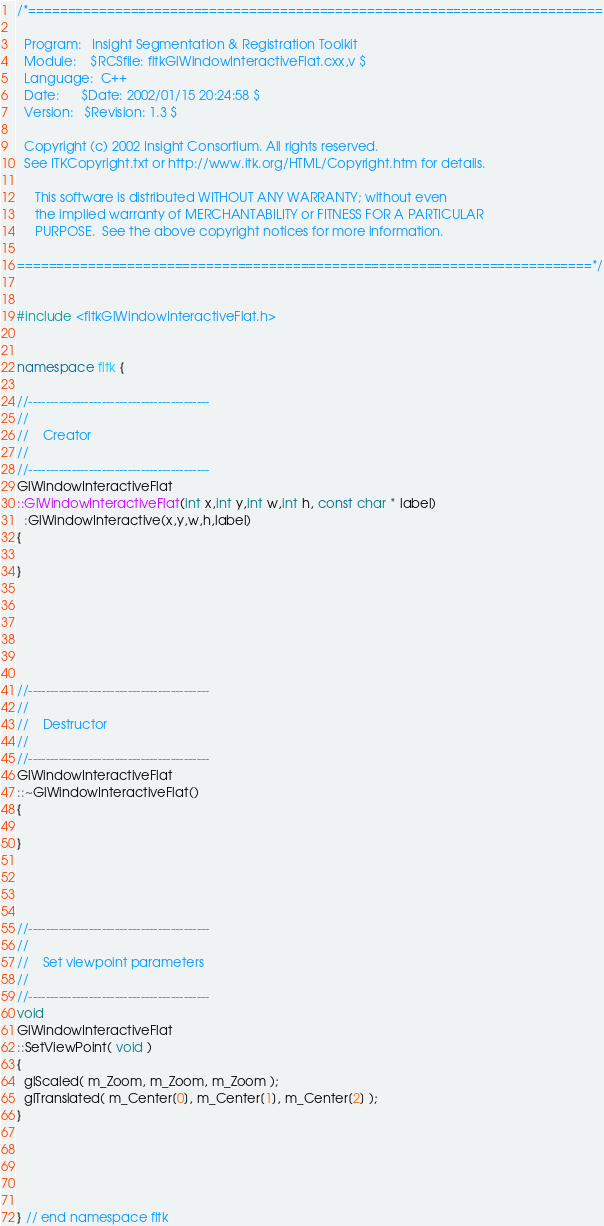<code> <loc_0><loc_0><loc_500><loc_500><_C++_>/*=========================================================================

  Program:   Insight Segmentation & Registration Toolkit
  Module:    $RCSfile: fltkGlWindowInteractiveFlat.cxx,v $
  Language:  C++
  Date:      $Date: 2002/01/15 20:24:58 $
  Version:   $Revision: 1.3 $

  Copyright (c) 2002 Insight Consortium. All rights reserved.
  See ITKCopyright.txt or http://www.itk.org/HTML/Copyright.htm for details.

     This software is distributed WITHOUT ANY WARRANTY; without even 
     the implied warranty of MERCHANTABILITY or FITNESS FOR A PARTICULAR 
     PURPOSE.  See the above copyright notices for more information.

=========================================================================*/


#include <fltkGlWindowInteractiveFlat.h>


namespace fltk {

//------------------------------------------
//
//    Creator
//
//------------------------------------------
GlWindowInteractiveFlat
::GlWindowInteractiveFlat(int x,int y,int w,int h, const char * label)
  :GlWindowInteractive(x,y,w,h,label) 
{

}






//------------------------------------------
//
//    Destructor
//
//------------------------------------------
GlWindowInteractiveFlat
::~GlWindowInteractiveFlat() 
{

}




//------------------------------------------
//
//    Set viewpoint parameters
//
//------------------------------------------
void 
GlWindowInteractiveFlat
::SetViewPoint( void ) 
{
  glScaled( m_Zoom, m_Zoom, m_Zoom );
  glTranslated( m_Center[0], m_Center[1], m_Center[2] );
}





} // end namespace fltk
</code> 